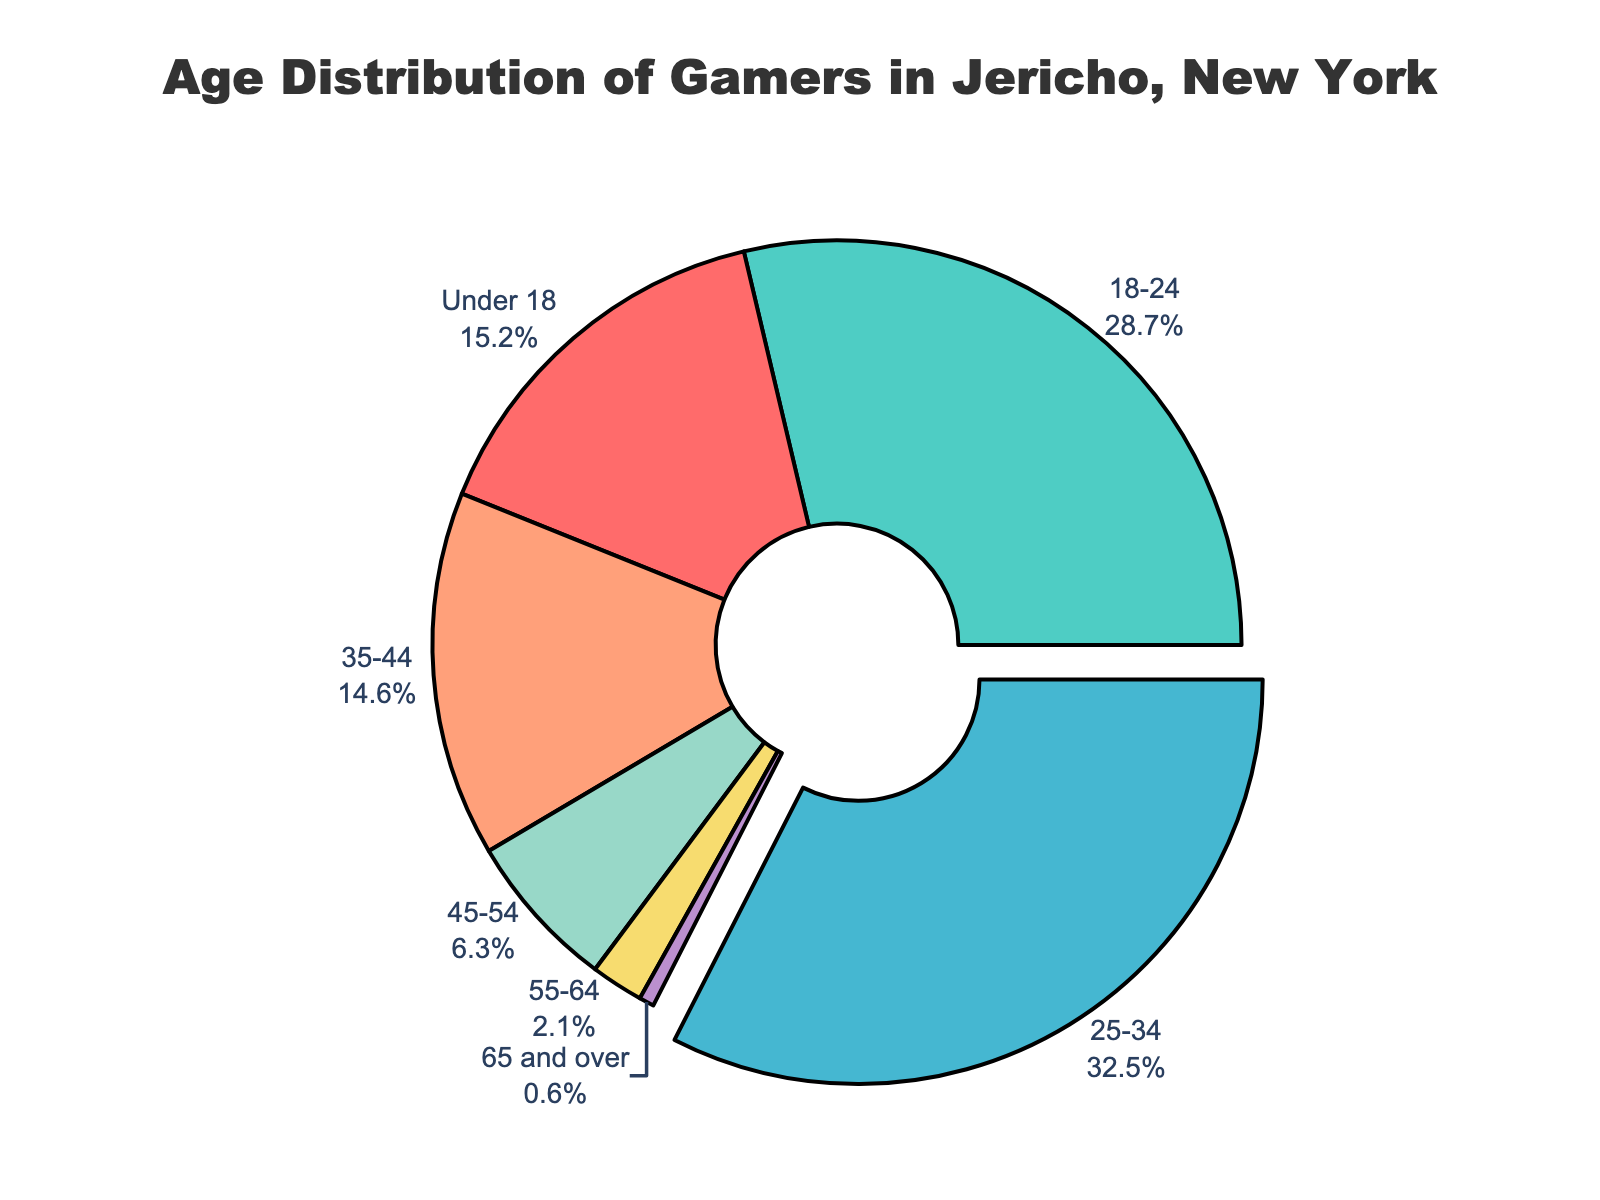What age group has the highest percentage of gamers? First, look at each segment of the pie chart to find the age group with the largest piece. The age group with the largest pie segment represents the highest percentage.
Answer: 25-34 Which age group has the lowest percentage of gamers? Examine the pie chart segments and identify the smallest segment. The smallest segment corresponds to the age group with the lowest percentage.
Answer: 65 and over How much larger is the percentage of gamers aged 18-24 compared to those aged 45-54? Find the percentages for the 18-24 and 45-54 age groups from the pie chart. Subtract the percentage for 45-54 from 18-24. The percentages are 28.7% and 6.3%, respectively. Thus, 28.7 - 6.3 = 22.4.
Answer: 22.4 By how much does the percentage of gamers aged 25-34 exceed those aged 35-44? Identify the percentages from the chart: 25-34 is 32.5%, and 35-44 is 14.6%. Subtract the two: 32.5 - 14.6 = 17.9.
Answer: 17.9 What is the combined percentage of gamers aged under 18 and those aged 55-64? Sum the percentages for under 18 and 55-64 from the chart: 15.2% + 2.1% = 17.3%.
Answer: 17.3 Which age group is represented by a segment pulled slightly out of the pie chart? Some pie charts pull out the largest segment for emphasis. Identify the pulled-out segment, which represents the 25-34 age group.
Answer: 25-34 How do the combined percentages of gamers aged 35-44 and 45-54 compare to gamers aged 25-34? Find the percentages of each group from the chart: 35-44 is 14.6%, and 45-54 is 6.3%, totaling 14.6 + 6.3 = 20.9%. Compare this to 32.5% for the 25-34 group.
Answer: 25-34 is higher Which age group has more gamers, those under 18 or those aged 55 and over? Sum the percentages for the under 18 group (15.2%) and the 55+ groups (2.1% + 0.6% = 2.7%). Compare 15.2% to 2.7%.
Answer: Under 18 What is the percentage difference between the age groups of 18-24 and 35-44? Identify the percentages from the pie chart: 18-24 is 28.7%, and 35-44 is 14.6%. Subtract the smaller from the larger: 28.7 - 14.6 = 14.1.
Answer: 14.1 